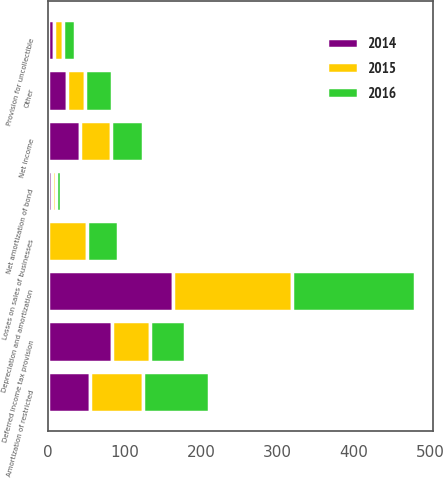<chart> <loc_0><loc_0><loc_500><loc_500><stacked_bar_chart><ecel><fcel>Net income<fcel>Depreciation and amortization<fcel>Provision for uncollectible<fcel>Amortization of restricted<fcel>Net amortization of bond<fcel>Deferred income tax provision<fcel>Losses on sales of businesses<fcel>Other<nl><fcel>2016<fcel>41.4<fcel>160.2<fcel>16.7<fcel>85.6<fcel>5.6<fcel>45.7<fcel>41.4<fcel>35.5<nl><fcel>2015<fcel>41.4<fcel>157<fcel>11.4<fcel>70.3<fcel>5.8<fcel>49.5<fcel>50.1<fcel>24.2<nl><fcel>2014<fcel>41.4<fcel>163<fcel>7.4<fcel>54.3<fcel>5.1<fcel>83.5<fcel>0.2<fcel>24.1<nl></chart> 